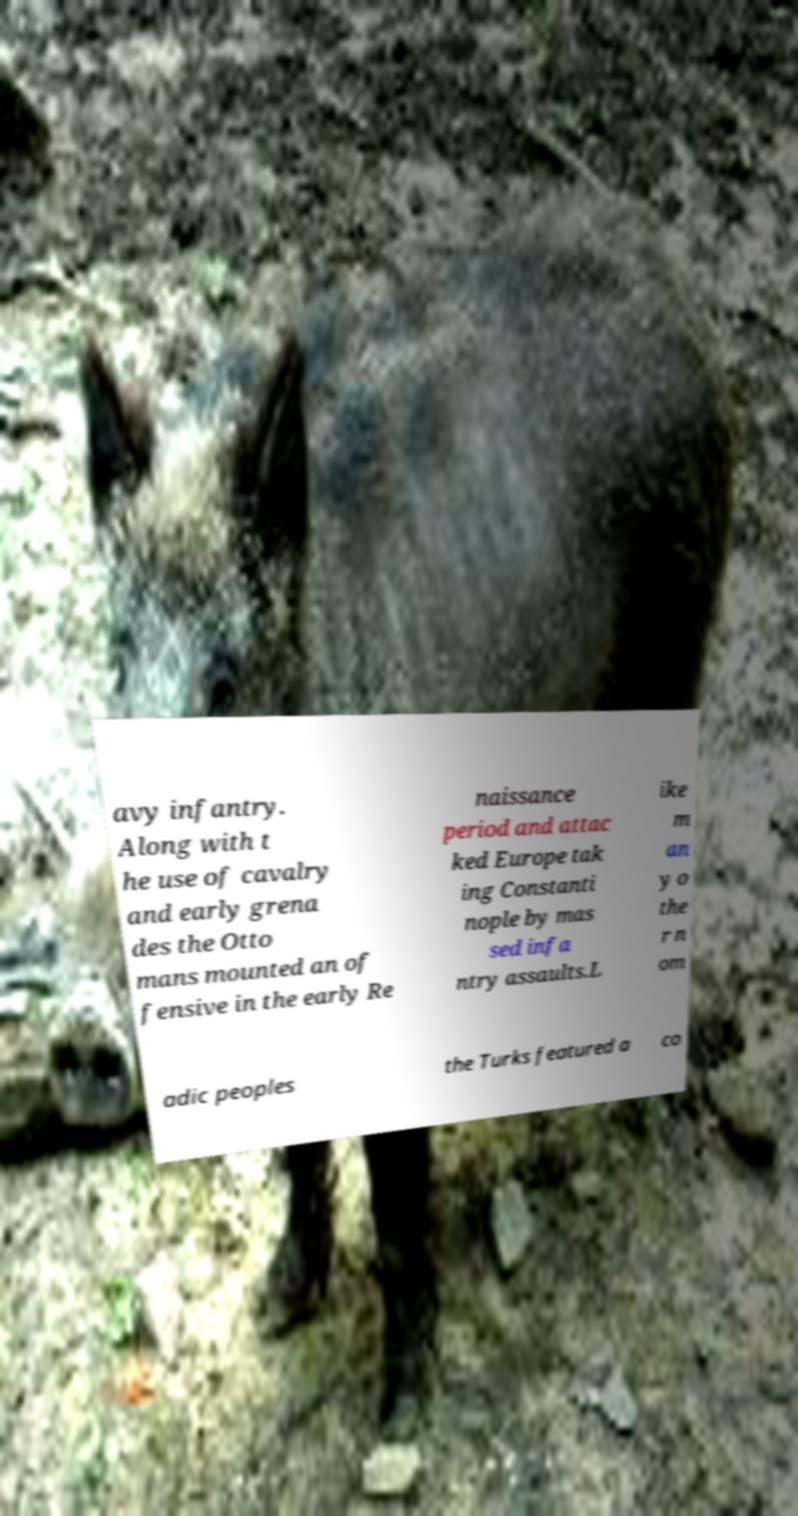Please read and relay the text visible in this image. What does it say? avy infantry. Along with t he use of cavalry and early grena des the Otto mans mounted an of fensive in the early Re naissance period and attac ked Europe tak ing Constanti nople by mas sed infa ntry assaults.L ike m an y o the r n om adic peoples the Turks featured a co 